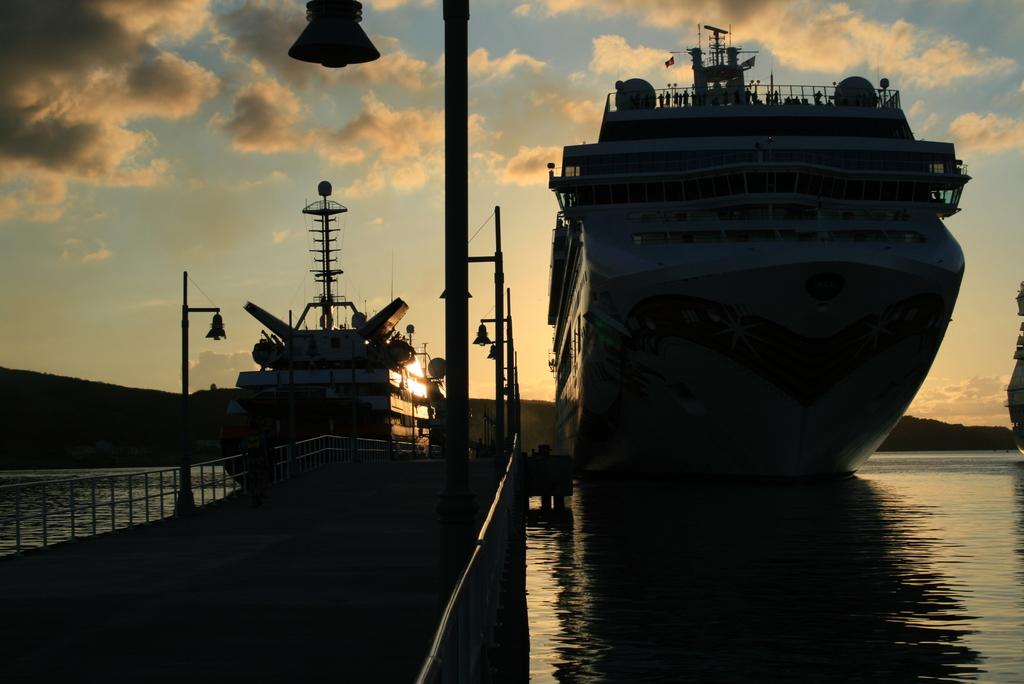What is located in the water in the image? There are ships in the water in the image. What type of structure can be seen in the image? There is a bridge in the image. How would you describe the sky in the image? The sky is blue and cloudy in the image. What type of lighting is present in the image? There are pole lights visible in the image. Can you see an owl perched on the bridge in the image? There is no owl present in the image; it only features ships, a bridge, the sky, and pole lights. What type of patch is visible on the ships in the image? There are no patches visible on the ships in the image; only the ships themselves, the bridge, the sky, and pole lights are present. 